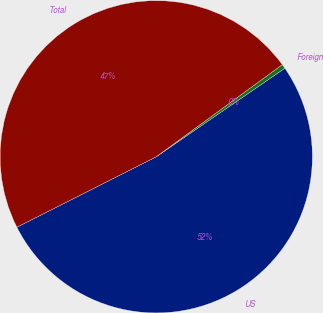Convert chart to OTSL. <chart><loc_0><loc_0><loc_500><loc_500><pie_chart><fcel>US<fcel>Foreign<fcel>Total<nl><fcel>52.14%<fcel>0.45%<fcel>47.4%<nl></chart> 